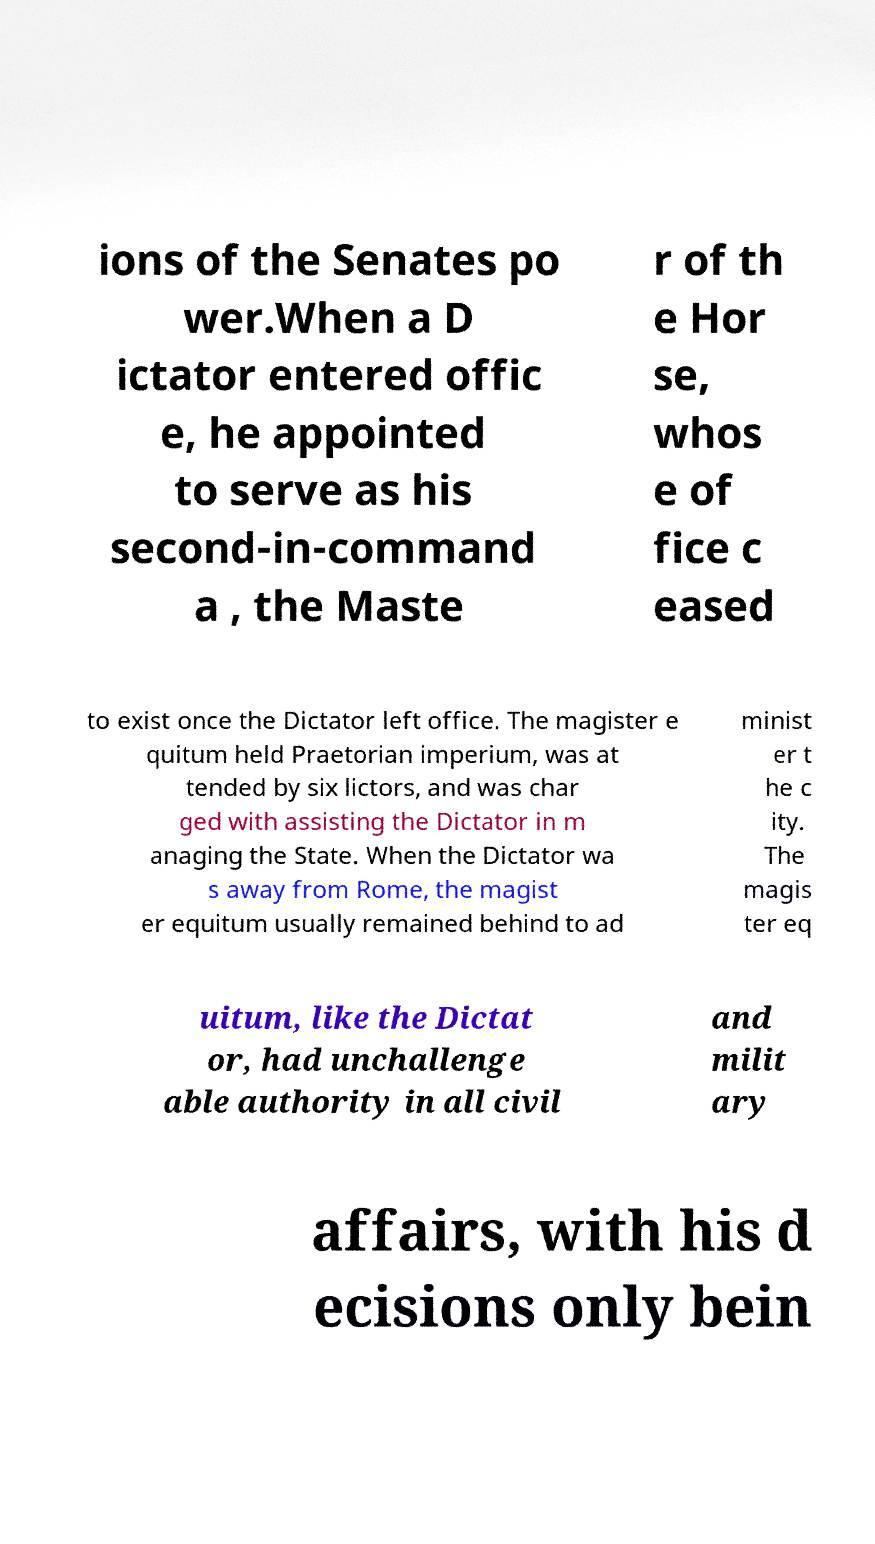Can you accurately transcribe the text from the provided image for me? ions of the Senates po wer.When a D ictator entered offic e, he appointed to serve as his second-in-command a , the Maste r of th e Hor se, whos e of fice c eased to exist once the Dictator left office. The magister e quitum held Praetorian imperium, was at tended by six lictors, and was char ged with assisting the Dictator in m anaging the State. When the Dictator wa s away from Rome, the magist er equitum usually remained behind to ad minist er t he c ity. The magis ter eq uitum, like the Dictat or, had unchallenge able authority in all civil and milit ary affairs, with his d ecisions only bein 